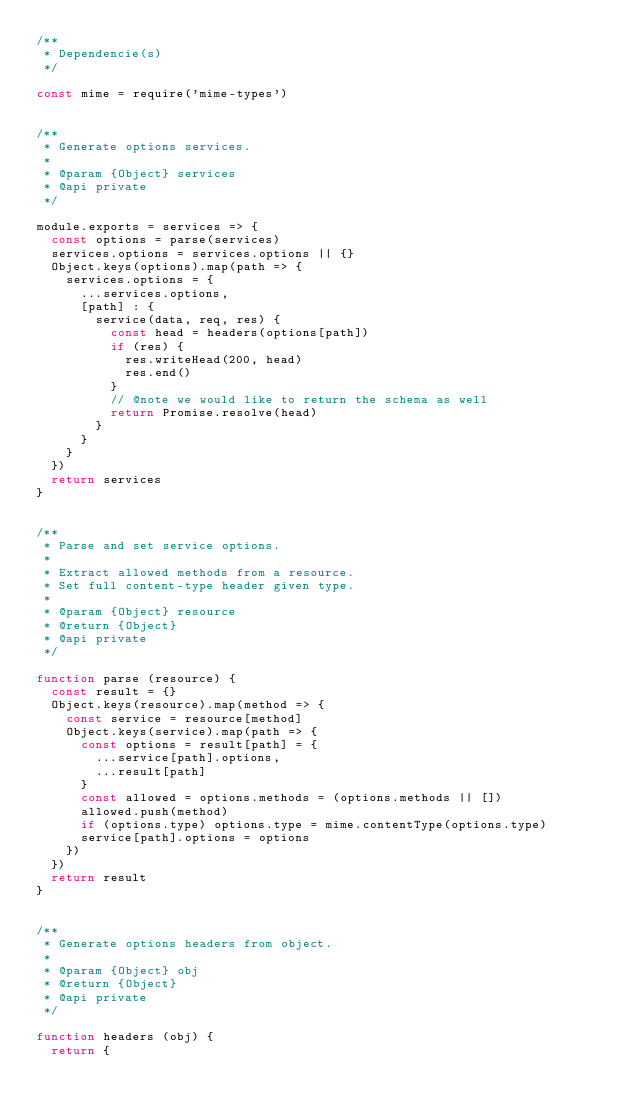Convert code to text. <code><loc_0><loc_0><loc_500><loc_500><_JavaScript_>/**
 * Dependencie(s)
 */

const mime = require('mime-types')


/**
 * Generate options services.
 *
 * @param {Object} services
 * @api private
 */

module.exports = services => {
  const options = parse(services)
  services.options = services.options || {}
  Object.keys(options).map(path => {
    services.options = {
      ...services.options,
      [path] : {
        service(data, req, res) {
          const head = headers(options[path])
          if (res) {
            res.writeHead(200, head)
            res.end()
          }
          // @note we would like to return the schema as well
          return Promise.resolve(head)
        }
      }
    }
  })
  return services
}


/**
 * Parse and set service options.
 *
 * Extract allowed methods from a resource.
 * Set full content-type header given type.
 *
 * @param {Object} resource
 * @return {Object}
 * @api private
 */

function parse (resource) {
  const result = {}
  Object.keys(resource).map(method => {
    const service = resource[method]
    Object.keys(service).map(path => {
      const options = result[path] = {
        ...service[path].options,
        ...result[path]
      }
      const allowed = options.methods = (options.methods || [])
      allowed.push(method)
      if (options.type) options.type = mime.contentType(options.type)
      service[path].options = options
    })
  })
  return result
}


/**
 * Generate options headers from object.
 *
 * @param {Object} obj
 * @return {Object}
 * @api private
 */

function headers (obj) {
  return {</code> 